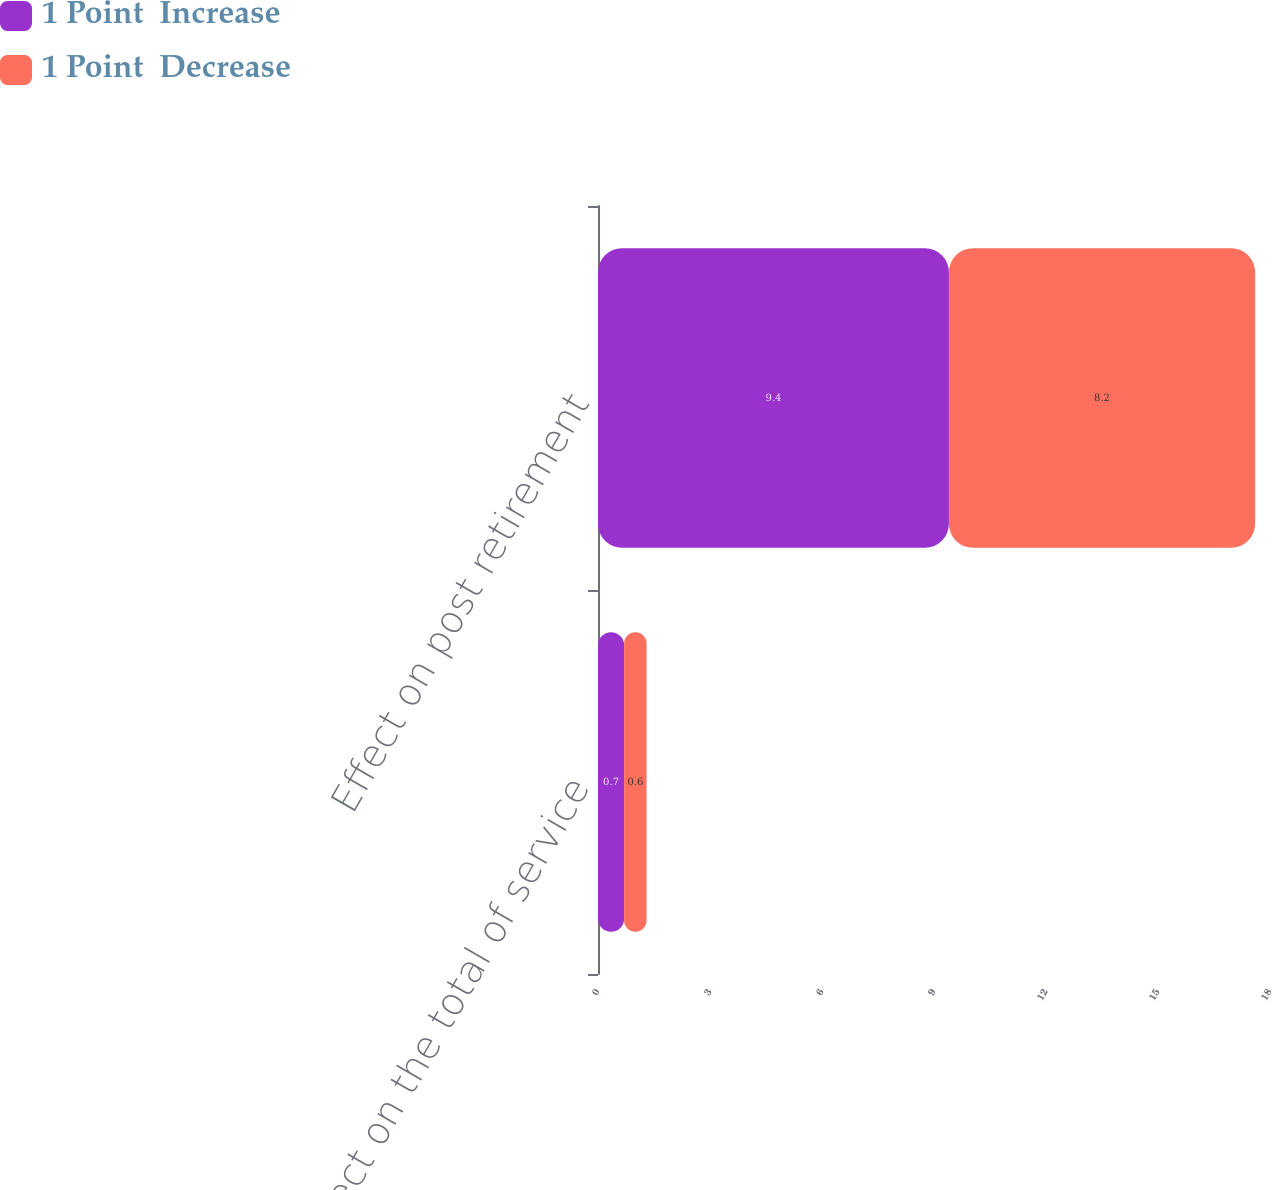Convert chart. <chart><loc_0><loc_0><loc_500><loc_500><stacked_bar_chart><ecel><fcel>Effect on the total of service<fcel>Effect on post retirement<nl><fcel>1 Point  Increase<fcel>0.7<fcel>9.4<nl><fcel>1 Point  Decrease<fcel>0.6<fcel>8.2<nl></chart> 